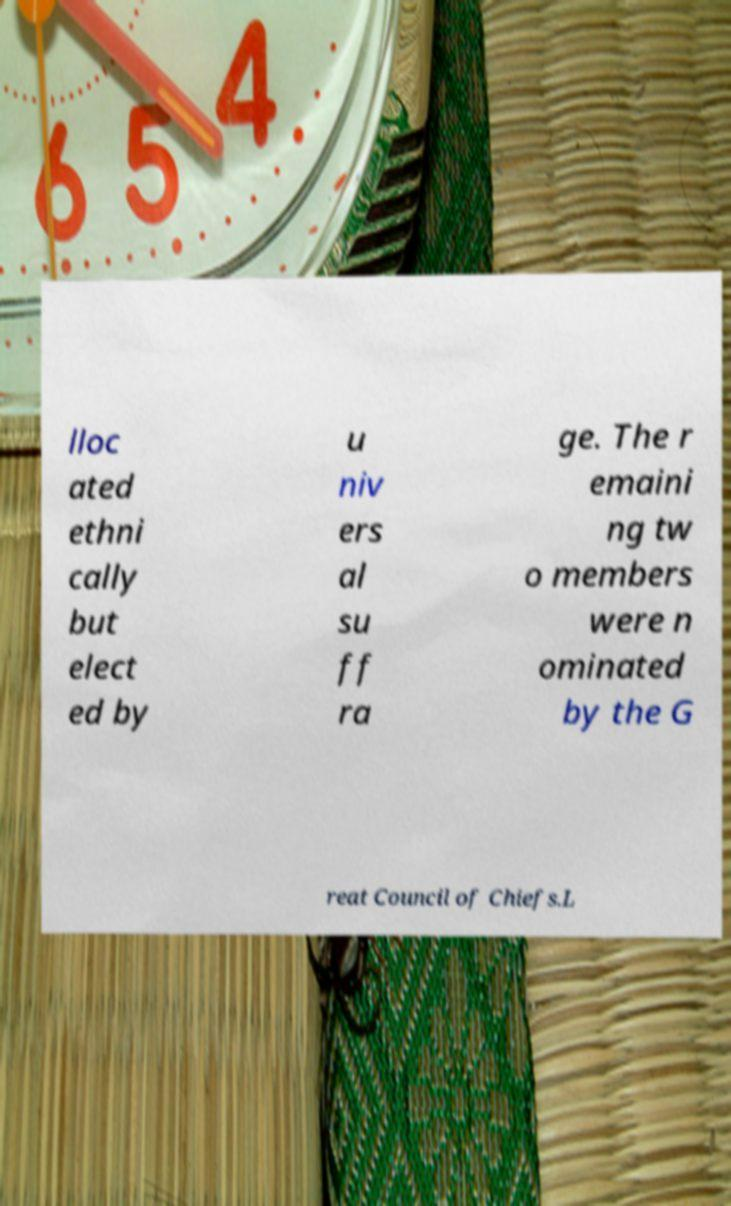Please read and relay the text visible in this image. What does it say? lloc ated ethni cally but elect ed by u niv ers al su ff ra ge. The r emaini ng tw o members were n ominated by the G reat Council of Chiefs.L 